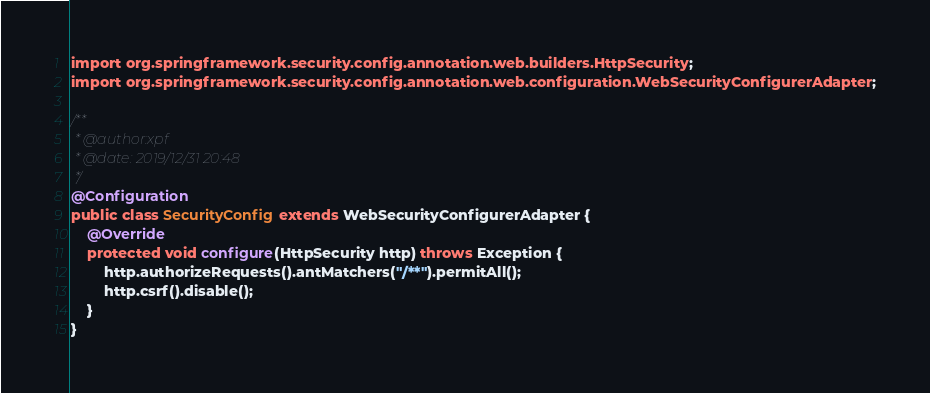Convert code to text. <code><loc_0><loc_0><loc_500><loc_500><_Java_>import org.springframework.security.config.annotation.web.builders.HttpSecurity;
import org.springframework.security.config.annotation.web.configuration.WebSecurityConfigurerAdapter;

/**
 * @author:xpf
 * @date: 2019/12/31 20:48
 */
@Configuration
public class SecurityConfig extends WebSecurityConfigurerAdapter {
    @Override
    protected void configure(HttpSecurity http) throws Exception {
        http.authorizeRequests().antMatchers("/**").permitAll();
        http.csrf().disable();
    }
}
</code> 